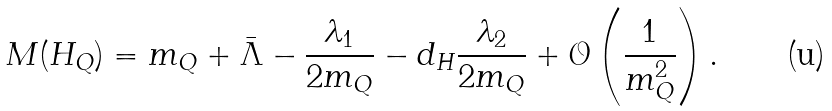Convert formula to latex. <formula><loc_0><loc_0><loc_500><loc_500>M ( H _ { Q } ) = m _ { Q } + \bar { \Lambda } - \frac { \lambda _ { 1 } } { 2 m _ { Q } } - d _ { H } \frac { \lambda _ { 2 } } { 2 m _ { Q } } + \mathcal { O } \left ( \frac { 1 } { m _ { Q } ^ { 2 } } \right ) .</formula> 